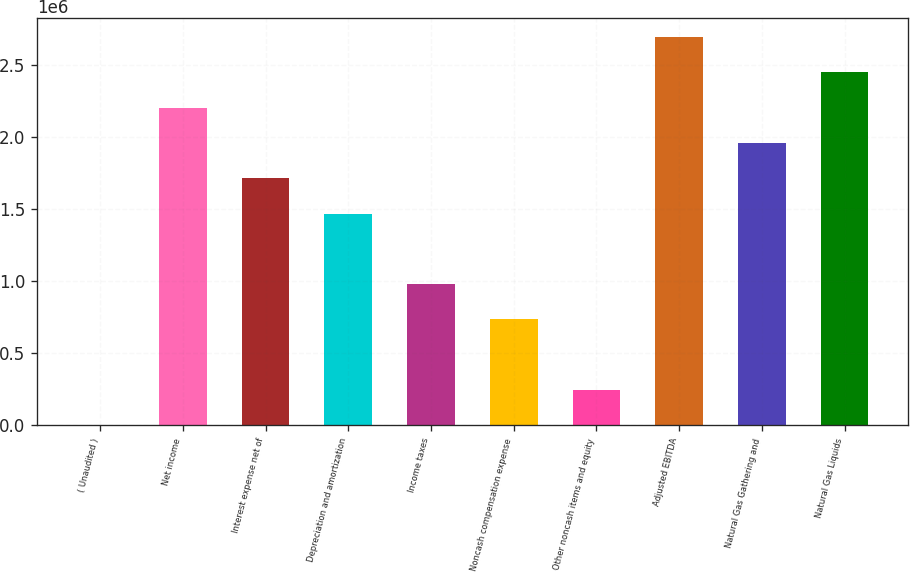Convert chart. <chart><loc_0><loc_0><loc_500><loc_500><bar_chart><fcel>( Unaudited )<fcel>Net income<fcel>Interest expense net of<fcel>Depreciation and amortization<fcel>Income taxes<fcel>Noncash compensation expense<fcel>Other noncash items and equity<fcel>Adjusted EBITDA<fcel>Natural Gas Gathering and<fcel>Natural Gas Liquids<nl><fcel>2018<fcel>2.20297e+06<fcel>1.71387e+06<fcel>1.46932e+06<fcel>980219<fcel>735669<fcel>246568<fcel>2.69207e+06<fcel>1.95842e+06<fcel>2.44752e+06<nl></chart> 